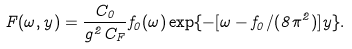<formula> <loc_0><loc_0><loc_500><loc_500>F ( \omega , y ) = \frac { C _ { 0 } } { g ^ { 2 } C _ { F } } f _ { 0 } ( \omega ) \exp \{ - [ \omega - f _ { 0 } / ( 8 \pi ^ { 2 } ) ] y \} .</formula> 